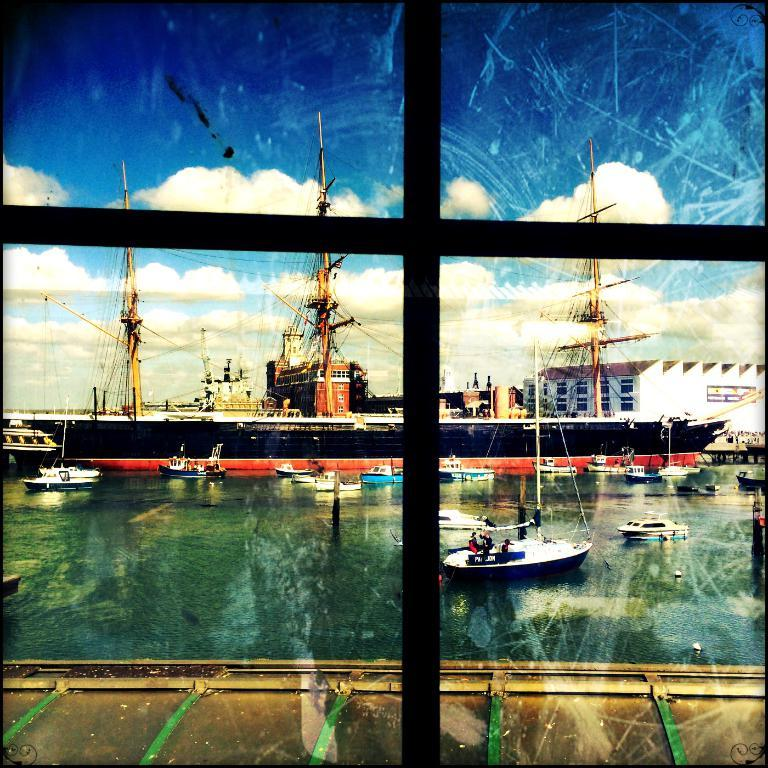What type of structure is present in the image? There is a building in the image. What feature can be observed on the building? The building has windows. What types of watercraft are visible in the image? There are ships and boats in the image. What is the primary setting for the watercraft? The water surface is visible in the image. What type of wall is present in the building? There is a glass wall in the image. What is the color of the sky in the image? The sky is blue and white in color. What is the invention that emits the scent in the image? There is no invention or scent present in the image. 